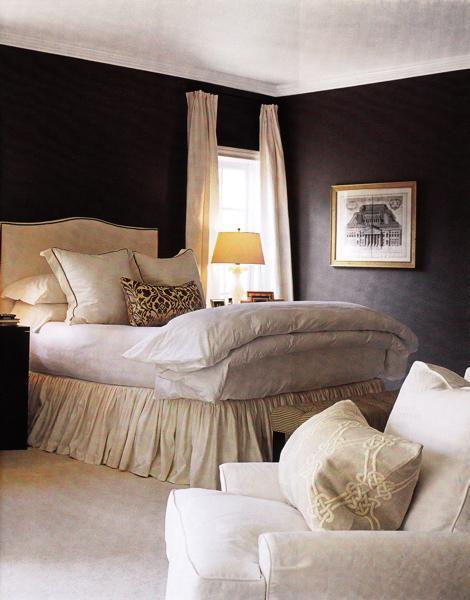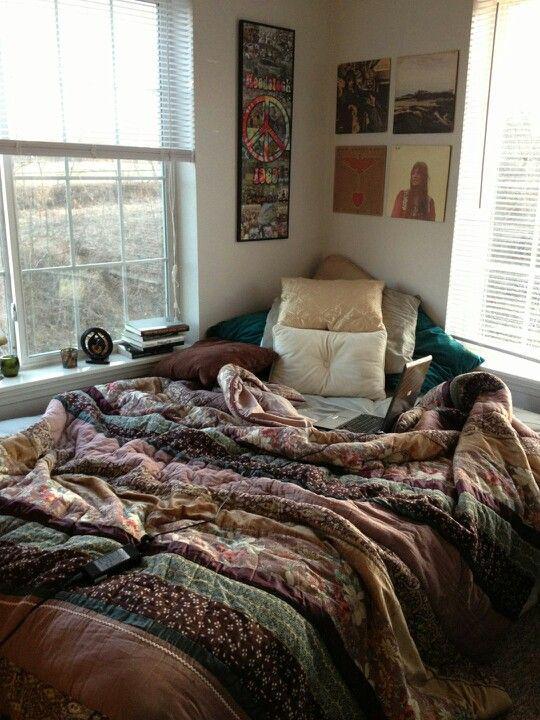The first image is the image on the left, the second image is the image on the right. Analyze the images presented: Is the assertion "There are flowers in a vase in one of the images." valid? Answer yes or no. No. 